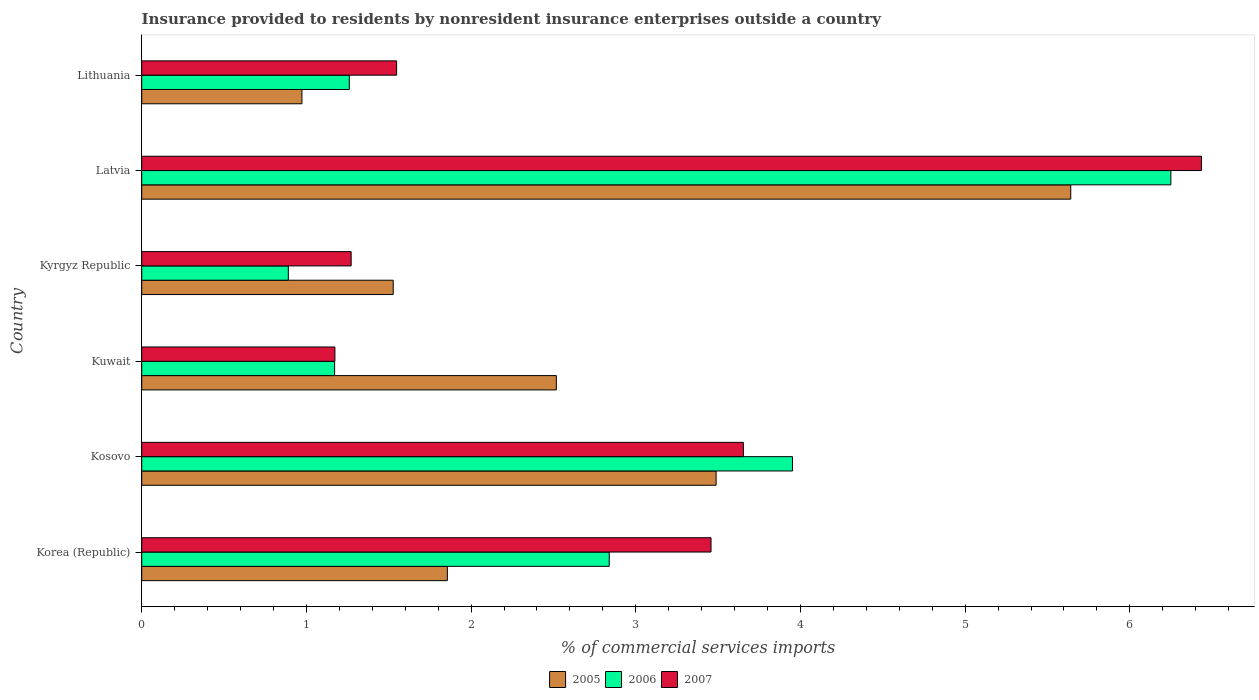Are the number of bars per tick equal to the number of legend labels?
Provide a succinct answer. Yes. Are the number of bars on each tick of the Y-axis equal?
Your answer should be very brief. Yes. In how many cases, is the number of bars for a given country not equal to the number of legend labels?
Offer a terse response. 0. What is the Insurance provided to residents in 2007 in Kuwait?
Provide a short and direct response. 1.17. Across all countries, what is the maximum Insurance provided to residents in 2006?
Ensure brevity in your answer.  6.25. Across all countries, what is the minimum Insurance provided to residents in 2005?
Your response must be concise. 0.97. In which country was the Insurance provided to residents in 2005 maximum?
Provide a short and direct response. Latvia. In which country was the Insurance provided to residents in 2006 minimum?
Provide a short and direct response. Kyrgyz Republic. What is the total Insurance provided to residents in 2005 in the graph?
Give a very brief answer. 16. What is the difference between the Insurance provided to residents in 2007 in Korea (Republic) and that in Kyrgyz Republic?
Your answer should be compact. 2.19. What is the difference between the Insurance provided to residents in 2007 in Kyrgyz Republic and the Insurance provided to residents in 2005 in Latvia?
Give a very brief answer. -4.37. What is the average Insurance provided to residents in 2007 per country?
Make the answer very short. 2.92. What is the difference between the Insurance provided to residents in 2006 and Insurance provided to residents in 2007 in Lithuania?
Make the answer very short. -0.29. In how many countries, is the Insurance provided to residents in 2006 greater than 3 %?
Your answer should be very brief. 2. What is the ratio of the Insurance provided to residents in 2006 in Korea (Republic) to that in Lithuania?
Make the answer very short. 2.25. Is the difference between the Insurance provided to residents in 2006 in Kosovo and Kuwait greater than the difference between the Insurance provided to residents in 2007 in Kosovo and Kuwait?
Offer a very short reply. Yes. What is the difference between the highest and the second highest Insurance provided to residents in 2006?
Offer a terse response. 2.3. What is the difference between the highest and the lowest Insurance provided to residents in 2005?
Your answer should be very brief. 4.67. Is the sum of the Insurance provided to residents in 2005 in Korea (Republic) and Kuwait greater than the maximum Insurance provided to residents in 2007 across all countries?
Ensure brevity in your answer.  No. What does the 2nd bar from the top in Latvia represents?
Your response must be concise. 2006. Is it the case that in every country, the sum of the Insurance provided to residents in 2006 and Insurance provided to residents in 2005 is greater than the Insurance provided to residents in 2007?
Provide a short and direct response. Yes. Are all the bars in the graph horizontal?
Keep it short and to the point. Yes. How many countries are there in the graph?
Offer a terse response. 6. What is the difference between two consecutive major ticks on the X-axis?
Offer a very short reply. 1. Does the graph contain grids?
Your answer should be very brief. No. How many legend labels are there?
Your response must be concise. 3. What is the title of the graph?
Your response must be concise. Insurance provided to residents by nonresident insurance enterprises outside a country. What is the label or title of the X-axis?
Your response must be concise. % of commercial services imports. What is the % of commercial services imports of 2005 in Korea (Republic)?
Your answer should be compact. 1.86. What is the % of commercial services imports of 2006 in Korea (Republic)?
Provide a succinct answer. 2.84. What is the % of commercial services imports of 2007 in Korea (Republic)?
Give a very brief answer. 3.46. What is the % of commercial services imports in 2005 in Kosovo?
Your answer should be compact. 3.49. What is the % of commercial services imports of 2006 in Kosovo?
Your response must be concise. 3.95. What is the % of commercial services imports in 2007 in Kosovo?
Provide a succinct answer. 3.65. What is the % of commercial services imports in 2005 in Kuwait?
Ensure brevity in your answer.  2.52. What is the % of commercial services imports of 2006 in Kuwait?
Your response must be concise. 1.17. What is the % of commercial services imports of 2007 in Kuwait?
Provide a short and direct response. 1.17. What is the % of commercial services imports in 2005 in Kyrgyz Republic?
Your answer should be compact. 1.53. What is the % of commercial services imports in 2006 in Kyrgyz Republic?
Your answer should be compact. 0.89. What is the % of commercial services imports in 2007 in Kyrgyz Republic?
Give a very brief answer. 1.27. What is the % of commercial services imports in 2005 in Latvia?
Your response must be concise. 5.64. What is the % of commercial services imports in 2006 in Latvia?
Keep it short and to the point. 6.25. What is the % of commercial services imports of 2007 in Latvia?
Give a very brief answer. 6.44. What is the % of commercial services imports of 2005 in Lithuania?
Your answer should be compact. 0.97. What is the % of commercial services imports of 2006 in Lithuania?
Keep it short and to the point. 1.26. What is the % of commercial services imports in 2007 in Lithuania?
Your answer should be very brief. 1.55. Across all countries, what is the maximum % of commercial services imports of 2005?
Offer a terse response. 5.64. Across all countries, what is the maximum % of commercial services imports in 2006?
Make the answer very short. 6.25. Across all countries, what is the maximum % of commercial services imports in 2007?
Keep it short and to the point. 6.44. Across all countries, what is the minimum % of commercial services imports of 2005?
Make the answer very short. 0.97. Across all countries, what is the minimum % of commercial services imports of 2006?
Provide a succinct answer. 0.89. Across all countries, what is the minimum % of commercial services imports of 2007?
Offer a very short reply. 1.17. What is the total % of commercial services imports in 2005 in the graph?
Make the answer very short. 16. What is the total % of commercial services imports in 2006 in the graph?
Provide a short and direct response. 16.36. What is the total % of commercial services imports of 2007 in the graph?
Give a very brief answer. 17.54. What is the difference between the % of commercial services imports of 2005 in Korea (Republic) and that in Kosovo?
Your answer should be compact. -1.63. What is the difference between the % of commercial services imports in 2006 in Korea (Republic) and that in Kosovo?
Keep it short and to the point. -1.11. What is the difference between the % of commercial services imports in 2007 in Korea (Republic) and that in Kosovo?
Offer a terse response. -0.2. What is the difference between the % of commercial services imports in 2005 in Korea (Republic) and that in Kuwait?
Keep it short and to the point. -0.66. What is the difference between the % of commercial services imports of 2006 in Korea (Republic) and that in Kuwait?
Make the answer very short. 1.67. What is the difference between the % of commercial services imports of 2007 in Korea (Republic) and that in Kuwait?
Ensure brevity in your answer.  2.28. What is the difference between the % of commercial services imports in 2005 in Korea (Republic) and that in Kyrgyz Republic?
Your answer should be compact. 0.33. What is the difference between the % of commercial services imports in 2006 in Korea (Republic) and that in Kyrgyz Republic?
Provide a succinct answer. 1.95. What is the difference between the % of commercial services imports of 2007 in Korea (Republic) and that in Kyrgyz Republic?
Offer a very short reply. 2.19. What is the difference between the % of commercial services imports in 2005 in Korea (Republic) and that in Latvia?
Give a very brief answer. -3.79. What is the difference between the % of commercial services imports of 2006 in Korea (Republic) and that in Latvia?
Provide a succinct answer. -3.41. What is the difference between the % of commercial services imports of 2007 in Korea (Republic) and that in Latvia?
Make the answer very short. -2.98. What is the difference between the % of commercial services imports in 2005 in Korea (Republic) and that in Lithuania?
Provide a short and direct response. 0.88. What is the difference between the % of commercial services imports in 2006 in Korea (Republic) and that in Lithuania?
Ensure brevity in your answer.  1.58. What is the difference between the % of commercial services imports in 2007 in Korea (Republic) and that in Lithuania?
Your response must be concise. 1.91. What is the difference between the % of commercial services imports in 2005 in Kosovo and that in Kuwait?
Ensure brevity in your answer.  0.97. What is the difference between the % of commercial services imports in 2006 in Kosovo and that in Kuwait?
Provide a short and direct response. 2.78. What is the difference between the % of commercial services imports of 2007 in Kosovo and that in Kuwait?
Make the answer very short. 2.48. What is the difference between the % of commercial services imports in 2005 in Kosovo and that in Kyrgyz Republic?
Provide a succinct answer. 1.96. What is the difference between the % of commercial services imports of 2006 in Kosovo and that in Kyrgyz Republic?
Keep it short and to the point. 3.06. What is the difference between the % of commercial services imports of 2007 in Kosovo and that in Kyrgyz Republic?
Your answer should be very brief. 2.38. What is the difference between the % of commercial services imports in 2005 in Kosovo and that in Latvia?
Make the answer very short. -2.15. What is the difference between the % of commercial services imports of 2006 in Kosovo and that in Latvia?
Offer a very short reply. -2.3. What is the difference between the % of commercial services imports of 2007 in Kosovo and that in Latvia?
Offer a terse response. -2.78. What is the difference between the % of commercial services imports of 2005 in Kosovo and that in Lithuania?
Offer a very short reply. 2.51. What is the difference between the % of commercial services imports of 2006 in Kosovo and that in Lithuania?
Give a very brief answer. 2.69. What is the difference between the % of commercial services imports in 2007 in Kosovo and that in Lithuania?
Provide a succinct answer. 2.11. What is the difference between the % of commercial services imports of 2005 in Kuwait and that in Kyrgyz Republic?
Your answer should be compact. 0.99. What is the difference between the % of commercial services imports of 2006 in Kuwait and that in Kyrgyz Republic?
Your response must be concise. 0.28. What is the difference between the % of commercial services imports of 2007 in Kuwait and that in Kyrgyz Republic?
Your answer should be compact. -0.1. What is the difference between the % of commercial services imports in 2005 in Kuwait and that in Latvia?
Your answer should be very brief. -3.12. What is the difference between the % of commercial services imports of 2006 in Kuwait and that in Latvia?
Provide a short and direct response. -5.08. What is the difference between the % of commercial services imports in 2007 in Kuwait and that in Latvia?
Offer a very short reply. -5.26. What is the difference between the % of commercial services imports of 2005 in Kuwait and that in Lithuania?
Your answer should be very brief. 1.54. What is the difference between the % of commercial services imports in 2006 in Kuwait and that in Lithuania?
Your answer should be very brief. -0.09. What is the difference between the % of commercial services imports in 2007 in Kuwait and that in Lithuania?
Offer a very short reply. -0.37. What is the difference between the % of commercial services imports in 2005 in Kyrgyz Republic and that in Latvia?
Provide a succinct answer. -4.11. What is the difference between the % of commercial services imports in 2006 in Kyrgyz Republic and that in Latvia?
Offer a terse response. -5.36. What is the difference between the % of commercial services imports of 2007 in Kyrgyz Republic and that in Latvia?
Provide a succinct answer. -5.16. What is the difference between the % of commercial services imports in 2005 in Kyrgyz Republic and that in Lithuania?
Your answer should be very brief. 0.55. What is the difference between the % of commercial services imports in 2006 in Kyrgyz Republic and that in Lithuania?
Ensure brevity in your answer.  -0.37. What is the difference between the % of commercial services imports in 2007 in Kyrgyz Republic and that in Lithuania?
Your answer should be compact. -0.28. What is the difference between the % of commercial services imports of 2005 in Latvia and that in Lithuania?
Keep it short and to the point. 4.67. What is the difference between the % of commercial services imports of 2006 in Latvia and that in Lithuania?
Offer a very short reply. 4.99. What is the difference between the % of commercial services imports of 2007 in Latvia and that in Lithuania?
Your answer should be very brief. 4.89. What is the difference between the % of commercial services imports of 2005 in Korea (Republic) and the % of commercial services imports of 2006 in Kosovo?
Offer a very short reply. -2.1. What is the difference between the % of commercial services imports of 2005 in Korea (Republic) and the % of commercial services imports of 2007 in Kosovo?
Ensure brevity in your answer.  -1.8. What is the difference between the % of commercial services imports in 2006 in Korea (Republic) and the % of commercial services imports in 2007 in Kosovo?
Provide a succinct answer. -0.81. What is the difference between the % of commercial services imports in 2005 in Korea (Republic) and the % of commercial services imports in 2006 in Kuwait?
Offer a terse response. 0.68. What is the difference between the % of commercial services imports in 2005 in Korea (Republic) and the % of commercial services imports in 2007 in Kuwait?
Provide a succinct answer. 0.68. What is the difference between the % of commercial services imports of 2006 in Korea (Republic) and the % of commercial services imports of 2007 in Kuwait?
Provide a short and direct response. 1.67. What is the difference between the % of commercial services imports of 2005 in Korea (Republic) and the % of commercial services imports of 2006 in Kyrgyz Republic?
Your answer should be compact. 0.97. What is the difference between the % of commercial services imports in 2005 in Korea (Republic) and the % of commercial services imports in 2007 in Kyrgyz Republic?
Provide a succinct answer. 0.58. What is the difference between the % of commercial services imports in 2006 in Korea (Republic) and the % of commercial services imports in 2007 in Kyrgyz Republic?
Provide a short and direct response. 1.57. What is the difference between the % of commercial services imports in 2005 in Korea (Republic) and the % of commercial services imports in 2006 in Latvia?
Offer a terse response. -4.39. What is the difference between the % of commercial services imports in 2005 in Korea (Republic) and the % of commercial services imports in 2007 in Latvia?
Give a very brief answer. -4.58. What is the difference between the % of commercial services imports of 2006 in Korea (Republic) and the % of commercial services imports of 2007 in Latvia?
Provide a short and direct response. -3.6. What is the difference between the % of commercial services imports in 2005 in Korea (Republic) and the % of commercial services imports in 2006 in Lithuania?
Ensure brevity in your answer.  0.6. What is the difference between the % of commercial services imports of 2005 in Korea (Republic) and the % of commercial services imports of 2007 in Lithuania?
Your answer should be compact. 0.31. What is the difference between the % of commercial services imports of 2006 in Korea (Republic) and the % of commercial services imports of 2007 in Lithuania?
Make the answer very short. 1.29. What is the difference between the % of commercial services imports of 2005 in Kosovo and the % of commercial services imports of 2006 in Kuwait?
Give a very brief answer. 2.32. What is the difference between the % of commercial services imports in 2005 in Kosovo and the % of commercial services imports in 2007 in Kuwait?
Give a very brief answer. 2.31. What is the difference between the % of commercial services imports of 2006 in Kosovo and the % of commercial services imports of 2007 in Kuwait?
Make the answer very short. 2.78. What is the difference between the % of commercial services imports of 2005 in Kosovo and the % of commercial services imports of 2006 in Kyrgyz Republic?
Ensure brevity in your answer.  2.6. What is the difference between the % of commercial services imports of 2005 in Kosovo and the % of commercial services imports of 2007 in Kyrgyz Republic?
Keep it short and to the point. 2.22. What is the difference between the % of commercial services imports of 2006 in Kosovo and the % of commercial services imports of 2007 in Kyrgyz Republic?
Give a very brief answer. 2.68. What is the difference between the % of commercial services imports of 2005 in Kosovo and the % of commercial services imports of 2006 in Latvia?
Make the answer very short. -2.76. What is the difference between the % of commercial services imports of 2005 in Kosovo and the % of commercial services imports of 2007 in Latvia?
Ensure brevity in your answer.  -2.95. What is the difference between the % of commercial services imports of 2006 in Kosovo and the % of commercial services imports of 2007 in Latvia?
Your answer should be very brief. -2.48. What is the difference between the % of commercial services imports of 2005 in Kosovo and the % of commercial services imports of 2006 in Lithuania?
Offer a very short reply. 2.23. What is the difference between the % of commercial services imports in 2005 in Kosovo and the % of commercial services imports in 2007 in Lithuania?
Keep it short and to the point. 1.94. What is the difference between the % of commercial services imports of 2006 in Kosovo and the % of commercial services imports of 2007 in Lithuania?
Give a very brief answer. 2.4. What is the difference between the % of commercial services imports of 2005 in Kuwait and the % of commercial services imports of 2006 in Kyrgyz Republic?
Give a very brief answer. 1.63. What is the difference between the % of commercial services imports of 2005 in Kuwait and the % of commercial services imports of 2007 in Kyrgyz Republic?
Your answer should be very brief. 1.25. What is the difference between the % of commercial services imports of 2006 in Kuwait and the % of commercial services imports of 2007 in Kyrgyz Republic?
Provide a short and direct response. -0.1. What is the difference between the % of commercial services imports in 2005 in Kuwait and the % of commercial services imports in 2006 in Latvia?
Your answer should be compact. -3.73. What is the difference between the % of commercial services imports in 2005 in Kuwait and the % of commercial services imports in 2007 in Latvia?
Provide a short and direct response. -3.92. What is the difference between the % of commercial services imports in 2006 in Kuwait and the % of commercial services imports in 2007 in Latvia?
Provide a succinct answer. -5.26. What is the difference between the % of commercial services imports of 2005 in Kuwait and the % of commercial services imports of 2006 in Lithuania?
Offer a terse response. 1.26. What is the difference between the % of commercial services imports of 2005 in Kuwait and the % of commercial services imports of 2007 in Lithuania?
Offer a terse response. 0.97. What is the difference between the % of commercial services imports in 2006 in Kuwait and the % of commercial services imports in 2007 in Lithuania?
Ensure brevity in your answer.  -0.38. What is the difference between the % of commercial services imports in 2005 in Kyrgyz Republic and the % of commercial services imports in 2006 in Latvia?
Your answer should be compact. -4.72. What is the difference between the % of commercial services imports of 2005 in Kyrgyz Republic and the % of commercial services imports of 2007 in Latvia?
Make the answer very short. -4.91. What is the difference between the % of commercial services imports of 2006 in Kyrgyz Republic and the % of commercial services imports of 2007 in Latvia?
Provide a succinct answer. -5.54. What is the difference between the % of commercial services imports in 2005 in Kyrgyz Republic and the % of commercial services imports in 2006 in Lithuania?
Give a very brief answer. 0.27. What is the difference between the % of commercial services imports in 2005 in Kyrgyz Republic and the % of commercial services imports in 2007 in Lithuania?
Provide a short and direct response. -0.02. What is the difference between the % of commercial services imports of 2006 in Kyrgyz Republic and the % of commercial services imports of 2007 in Lithuania?
Your answer should be very brief. -0.66. What is the difference between the % of commercial services imports in 2005 in Latvia and the % of commercial services imports in 2006 in Lithuania?
Make the answer very short. 4.38. What is the difference between the % of commercial services imports in 2005 in Latvia and the % of commercial services imports in 2007 in Lithuania?
Offer a very short reply. 4.09. What is the difference between the % of commercial services imports in 2006 in Latvia and the % of commercial services imports in 2007 in Lithuania?
Keep it short and to the point. 4.7. What is the average % of commercial services imports of 2005 per country?
Provide a short and direct response. 2.67. What is the average % of commercial services imports of 2006 per country?
Give a very brief answer. 2.73. What is the average % of commercial services imports in 2007 per country?
Offer a terse response. 2.92. What is the difference between the % of commercial services imports of 2005 and % of commercial services imports of 2006 in Korea (Republic)?
Keep it short and to the point. -0.98. What is the difference between the % of commercial services imports in 2005 and % of commercial services imports in 2007 in Korea (Republic)?
Your answer should be very brief. -1.6. What is the difference between the % of commercial services imports in 2006 and % of commercial services imports in 2007 in Korea (Republic)?
Your response must be concise. -0.62. What is the difference between the % of commercial services imports in 2005 and % of commercial services imports in 2006 in Kosovo?
Keep it short and to the point. -0.46. What is the difference between the % of commercial services imports in 2005 and % of commercial services imports in 2007 in Kosovo?
Ensure brevity in your answer.  -0.17. What is the difference between the % of commercial services imports of 2006 and % of commercial services imports of 2007 in Kosovo?
Your response must be concise. 0.3. What is the difference between the % of commercial services imports in 2005 and % of commercial services imports in 2006 in Kuwait?
Offer a very short reply. 1.35. What is the difference between the % of commercial services imports in 2005 and % of commercial services imports in 2007 in Kuwait?
Ensure brevity in your answer.  1.34. What is the difference between the % of commercial services imports of 2006 and % of commercial services imports of 2007 in Kuwait?
Your answer should be very brief. -0. What is the difference between the % of commercial services imports in 2005 and % of commercial services imports in 2006 in Kyrgyz Republic?
Offer a very short reply. 0.64. What is the difference between the % of commercial services imports in 2005 and % of commercial services imports in 2007 in Kyrgyz Republic?
Keep it short and to the point. 0.26. What is the difference between the % of commercial services imports of 2006 and % of commercial services imports of 2007 in Kyrgyz Republic?
Your response must be concise. -0.38. What is the difference between the % of commercial services imports in 2005 and % of commercial services imports in 2006 in Latvia?
Your answer should be very brief. -0.61. What is the difference between the % of commercial services imports of 2005 and % of commercial services imports of 2007 in Latvia?
Offer a very short reply. -0.79. What is the difference between the % of commercial services imports of 2006 and % of commercial services imports of 2007 in Latvia?
Offer a terse response. -0.19. What is the difference between the % of commercial services imports in 2005 and % of commercial services imports in 2006 in Lithuania?
Your answer should be very brief. -0.29. What is the difference between the % of commercial services imports in 2005 and % of commercial services imports in 2007 in Lithuania?
Provide a succinct answer. -0.57. What is the difference between the % of commercial services imports of 2006 and % of commercial services imports of 2007 in Lithuania?
Your response must be concise. -0.29. What is the ratio of the % of commercial services imports in 2005 in Korea (Republic) to that in Kosovo?
Offer a terse response. 0.53. What is the ratio of the % of commercial services imports in 2006 in Korea (Republic) to that in Kosovo?
Offer a terse response. 0.72. What is the ratio of the % of commercial services imports of 2007 in Korea (Republic) to that in Kosovo?
Provide a succinct answer. 0.95. What is the ratio of the % of commercial services imports in 2005 in Korea (Republic) to that in Kuwait?
Give a very brief answer. 0.74. What is the ratio of the % of commercial services imports in 2006 in Korea (Republic) to that in Kuwait?
Ensure brevity in your answer.  2.42. What is the ratio of the % of commercial services imports of 2007 in Korea (Republic) to that in Kuwait?
Provide a succinct answer. 2.95. What is the ratio of the % of commercial services imports of 2005 in Korea (Republic) to that in Kyrgyz Republic?
Provide a short and direct response. 1.22. What is the ratio of the % of commercial services imports in 2006 in Korea (Republic) to that in Kyrgyz Republic?
Provide a succinct answer. 3.19. What is the ratio of the % of commercial services imports in 2007 in Korea (Republic) to that in Kyrgyz Republic?
Your answer should be compact. 2.72. What is the ratio of the % of commercial services imports in 2005 in Korea (Republic) to that in Latvia?
Your response must be concise. 0.33. What is the ratio of the % of commercial services imports in 2006 in Korea (Republic) to that in Latvia?
Ensure brevity in your answer.  0.45. What is the ratio of the % of commercial services imports in 2007 in Korea (Republic) to that in Latvia?
Offer a very short reply. 0.54. What is the ratio of the % of commercial services imports of 2005 in Korea (Republic) to that in Lithuania?
Make the answer very short. 1.91. What is the ratio of the % of commercial services imports in 2006 in Korea (Republic) to that in Lithuania?
Offer a very short reply. 2.25. What is the ratio of the % of commercial services imports in 2007 in Korea (Republic) to that in Lithuania?
Keep it short and to the point. 2.23. What is the ratio of the % of commercial services imports in 2005 in Kosovo to that in Kuwait?
Offer a terse response. 1.39. What is the ratio of the % of commercial services imports in 2006 in Kosovo to that in Kuwait?
Offer a very short reply. 3.37. What is the ratio of the % of commercial services imports of 2007 in Kosovo to that in Kuwait?
Give a very brief answer. 3.11. What is the ratio of the % of commercial services imports in 2005 in Kosovo to that in Kyrgyz Republic?
Ensure brevity in your answer.  2.28. What is the ratio of the % of commercial services imports in 2006 in Kosovo to that in Kyrgyz Republic?
Your answer should be very brief. 4.44. What is the ratio of the % of commercial services imports of 2007 in Kosovo to that in Kyrgyz Republic?
Offer a terse response. 2.87. What is the ratio of the % of commercial services imports of 2005 in Kosovo to that in Latvia?
Offer a very short reply. 0.62. What is the ratio of the % of commercial services imports of 2006 in Kosovo to that in Latvia?
Keep it short and to the point. 0.63. What is the ratio of the % of commercial services imports in 2007 in Kosovo to that in Latvia?
Provide a short and direct response. 0.57. What is the ratio of the % of commercial services imports in 2005 in Kosovo to that in Lithuania?
Your response must be concise. 3.59. What is the ratio of the % of commercial services imports in 2006 in Kosovo to that in Lithuania?
Provide a succinct answer. 3.13. What is the ratio of the % of commercial services imports of 2007 in Kosovo to that in Lithuania?
Make the answer very short. 2.36. What is the ratio of the % of commercial services imports of 2005 in Kuwait to that in Kyrgyz Republic?
Offer a terse response. 1.65. What is the ratio of the % of commercial services imports of 2006 in Kuwait to that in Kyrgyz Republic?
Keep it short and to the point. 1.32. What is the ratio of the % of commercial services imports of 2007 in Kuwait to that in Kyrgyz Republic?
Your answer should be compact. 0.92. What is the ratio of the % of commercial services imports of 2005 in Kuwait to that in Latvia?
Your answer should be compact. 0.45. What is the ratio of the % of commercial services imports of 2006 in Kuwait to that in Latvia?
Keep it short and to the point. 0.19. What is the ratio of the % of commercial services imports in 2007 in Kuwait to that in Latvia?
Your answer should be compact. 0.18. What is the ratio of the % of commercial services imports of 2005 in Kuwait to that in Lithuania?
Keep it short and to the point. 2.59. What is the ratio of the % of commercial services imports of 2006 in Kuwait to that in Lithuania?
Provide a short and direct response. 0.93. What is the ratio of the % of commercial services imports of 2007 in Kuwait to that in Lithuania?
Keep it short and to the point. 0.76. What is the ratio of the % of commercial services imports of 2005 in Kyrgyz Republic to that in Latvia?
Offer a very short reply. 0.27. What is the ratio of the % of commercial services imports in 2006 in Kyrgyz Republic to that in Latvia?
Provide a succinct answer. 0.14. What is the ratio of the % of commercial services imports in 2007 in Kyrgyz Republic to that in Latvia?
Your response must be concise. 0.2. What is the ratio of the % of commercial services imports of 2005 in Kyrgyz Republic to that in Lithuania?
Offer a very short reply. 1.57. What is the ratio of the % of commercial services imports of 2006 in Kyrgyz Republic to that in Lithuania?
Ensure brevity in your answer.  0.71. What is the ratio of the % of commercial services imports of 2007 in Kyrgyz Republic to that in Lithuania?
Make the answer very short. 0.82. What is the ratio of the % of commercial services imports in 2005 in Latvia to that in Lithuania?
Your answer should be very brief. 5.8. What is the ratio of the % of commercial services imports of 2006 in Latvia to that in Lithuania?
Your response must be concise. 4.96. What is the ratio of the % of commercial services imports in 2007 in Latvia to that in Lithuania?
Your answer should be compact. 4.16. What is the difference between the highest and the second highest % of commercial services imports of 2005?
Offer a very short reply. 2.15. What is the difference between the highest and the second highest % of commercial services imports in 2006?
Provide a short and direct response. 2.3. What is the difference between the highest and the second highest % of commercial services imports of 2007?
Your answer should be compact. 2.78. What is the difference between the highest and the lowest % of commercial services imports of 2005?
Your response must be concise. 4.67. What is the difference between the highest and the lowest % of commercial services imports of 2006?
Make the answer very short. 5.36. What is the difference between the highest and the lowest % of commercial services imports of 2007?
Ensure brevity in your answer.  5.26. 